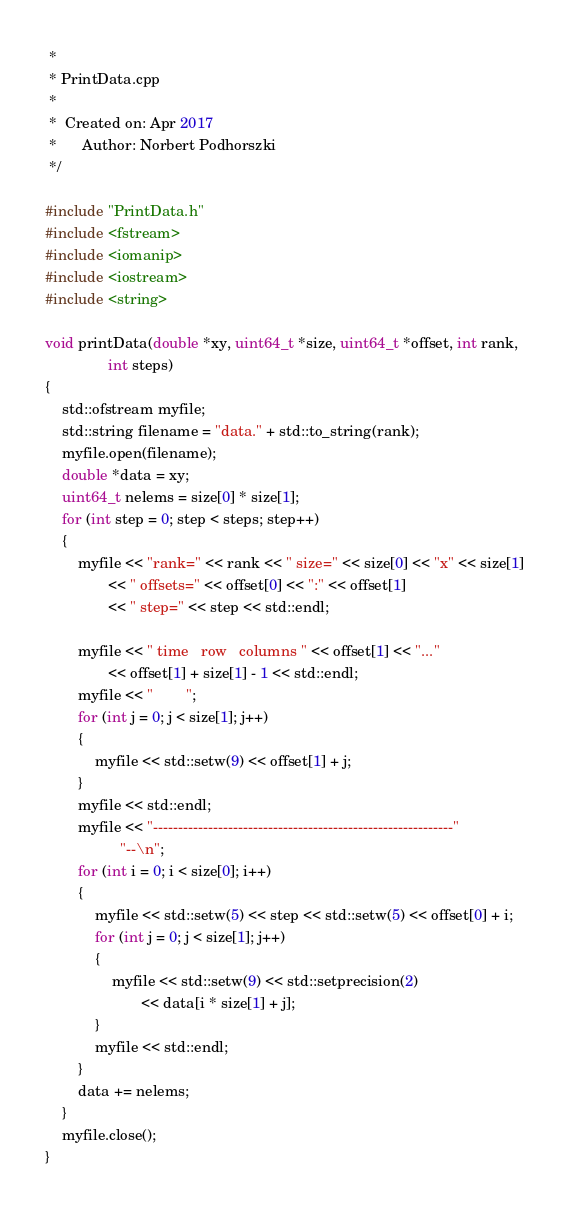<code> <loc_0><loc_0><loc_500><loc_500><_C++_> *
 * PrintData.cpp
 *
 *  Created on: Apr 2017
 *      Author: Norbert Podhorszki
 */

#include "PrintData.h"
#include <fstream>
#include <iomanip>
#include <iostream>
#include <string>

void printData(double *xy, uint64_t *size, uint64_t *offset, int rank,
               int steps)
{
    std::ofstream myfile;
    std::string filename = "data." + std::to_string(rank);
    myfile.open(filename);
    double *data = xy;
    uint64_t nelems = size[0] * size[1];
    for (int step = 0; step < steps; step++)
    {
        myfile << "rank=" << rank << " size=" << size[0] << "x" << size[1]
               << " offsets=" << offset[0] << ":" << offset[1]
               << " step=" << step << std::endl;

        myfile << " time   row   columns " << offset[1] << "..."
               << offset[1] + size[1] - 1 << std::endl;
        myfile << "        ";
        for (int j = 0; j < size[1]; j++)
        {
            myfile << std::setw(9) << offset[1] + j;
        }
        myfile << std::endl;
        myfile << "------------------------------------------------------------"
                  "--\n";
        for (int i = 0; i < size[0]; i++)
        {
            myfile << std::setw(5) << step << std::setw(5) << offset[0] + i;
            for (int j = 0; j < size[1]; j++)
            {
                myfile << std::setw(9) << std::setprecision(2)
                       << data[i * size[1] + j];
            }
            myfile << std::endl;
        }
        data += nelems;
    }
    myfile.close();
}
</code> 